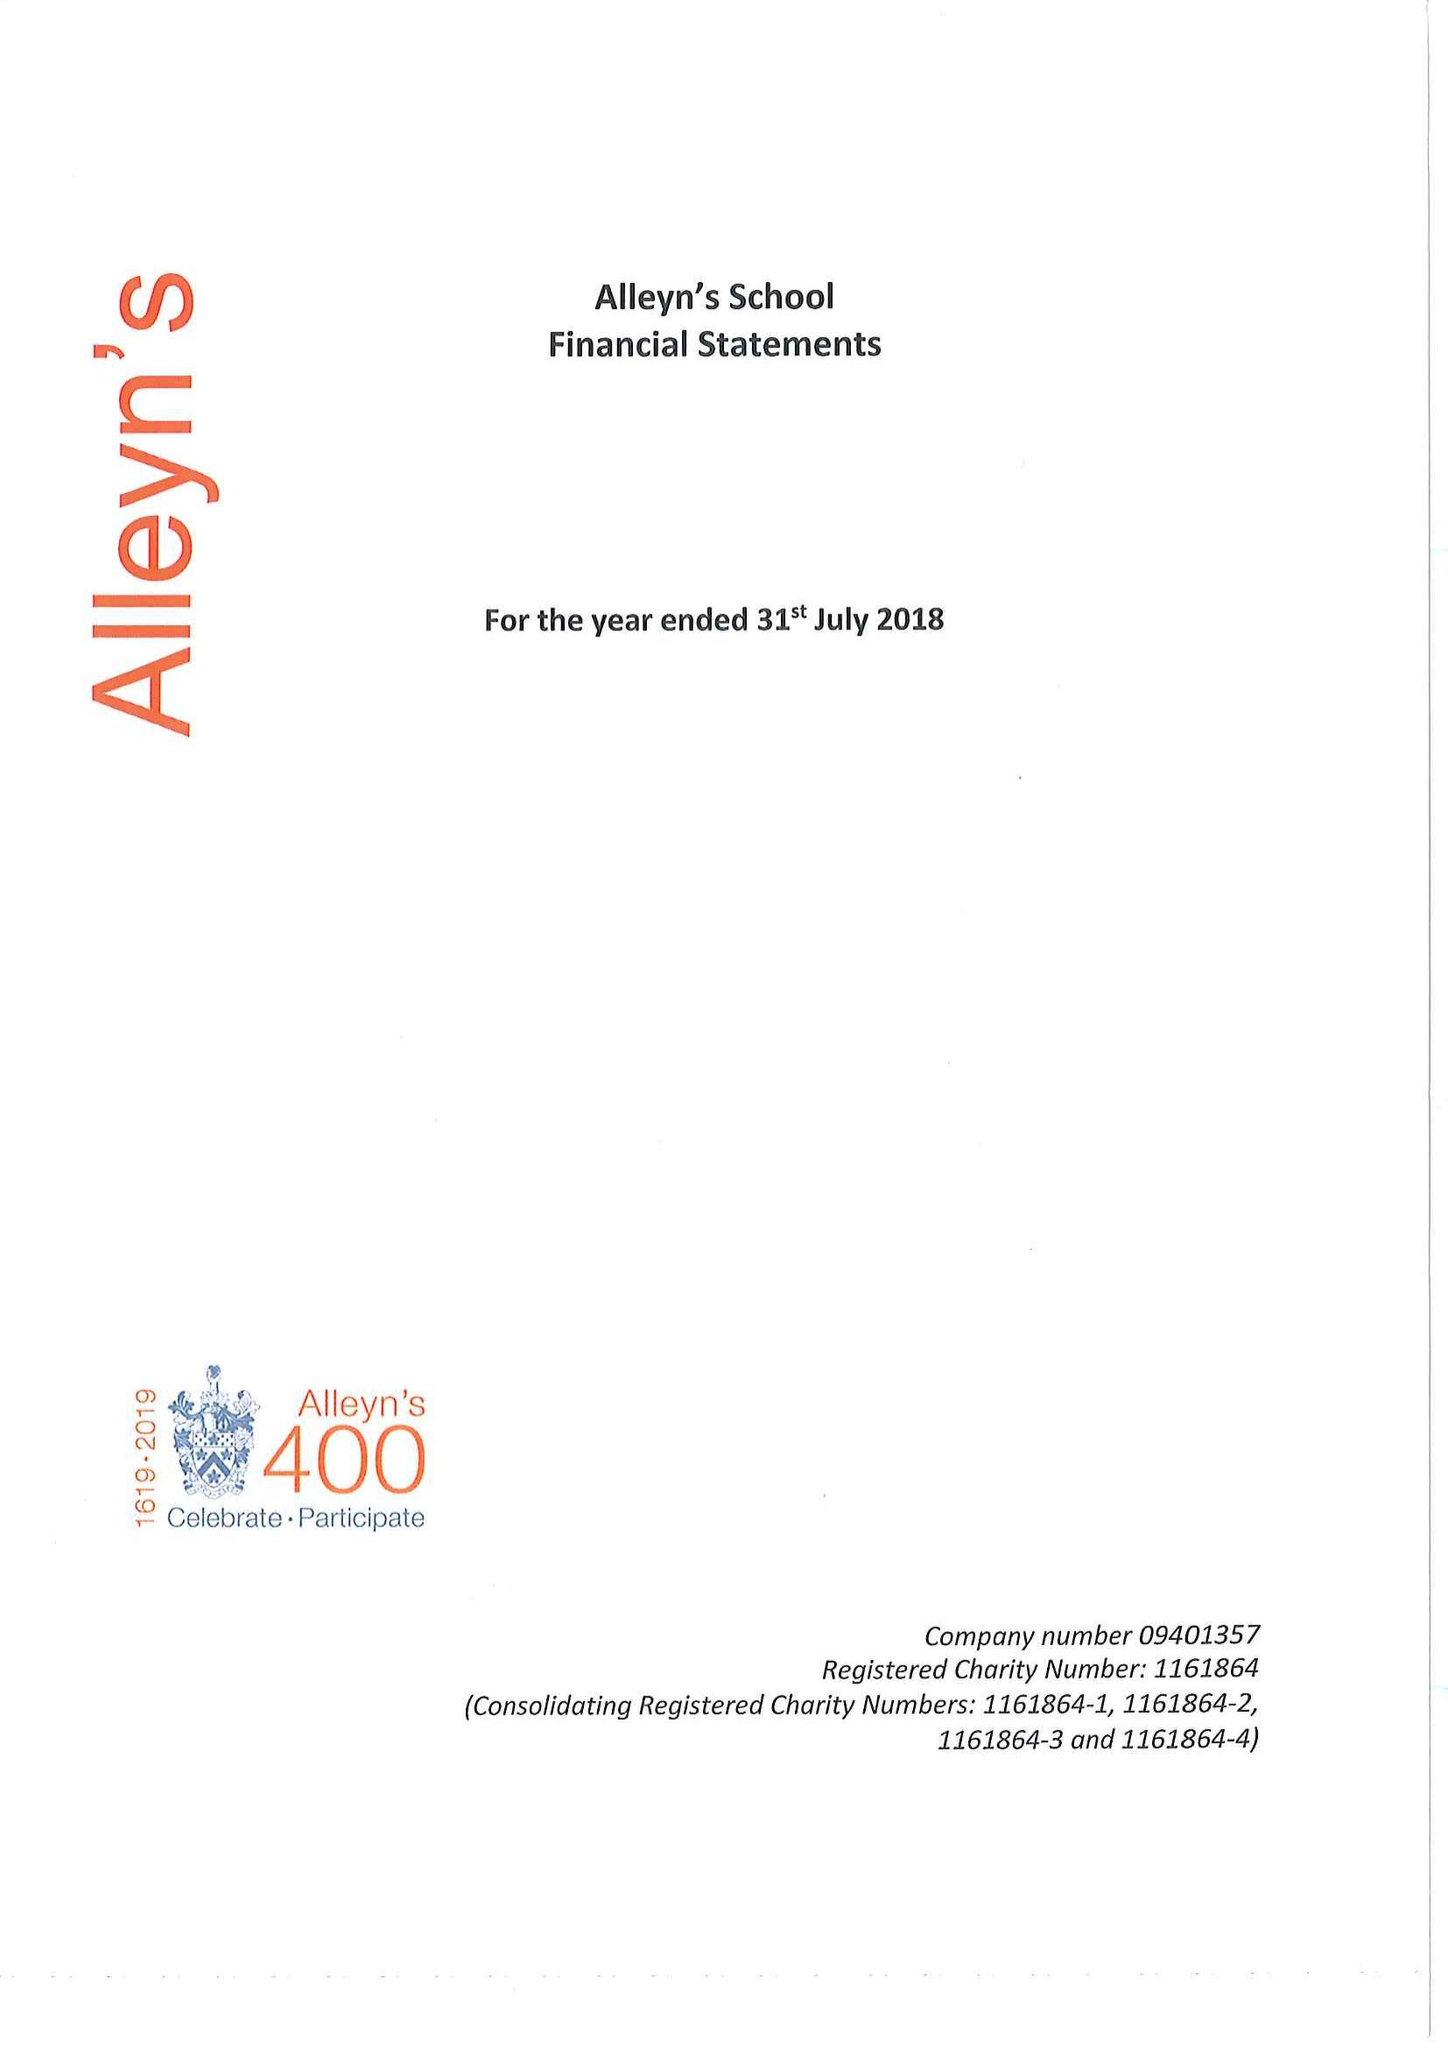What is the value for the charity_name?
Answer the question using a single word or phrase. Alleyn's School 